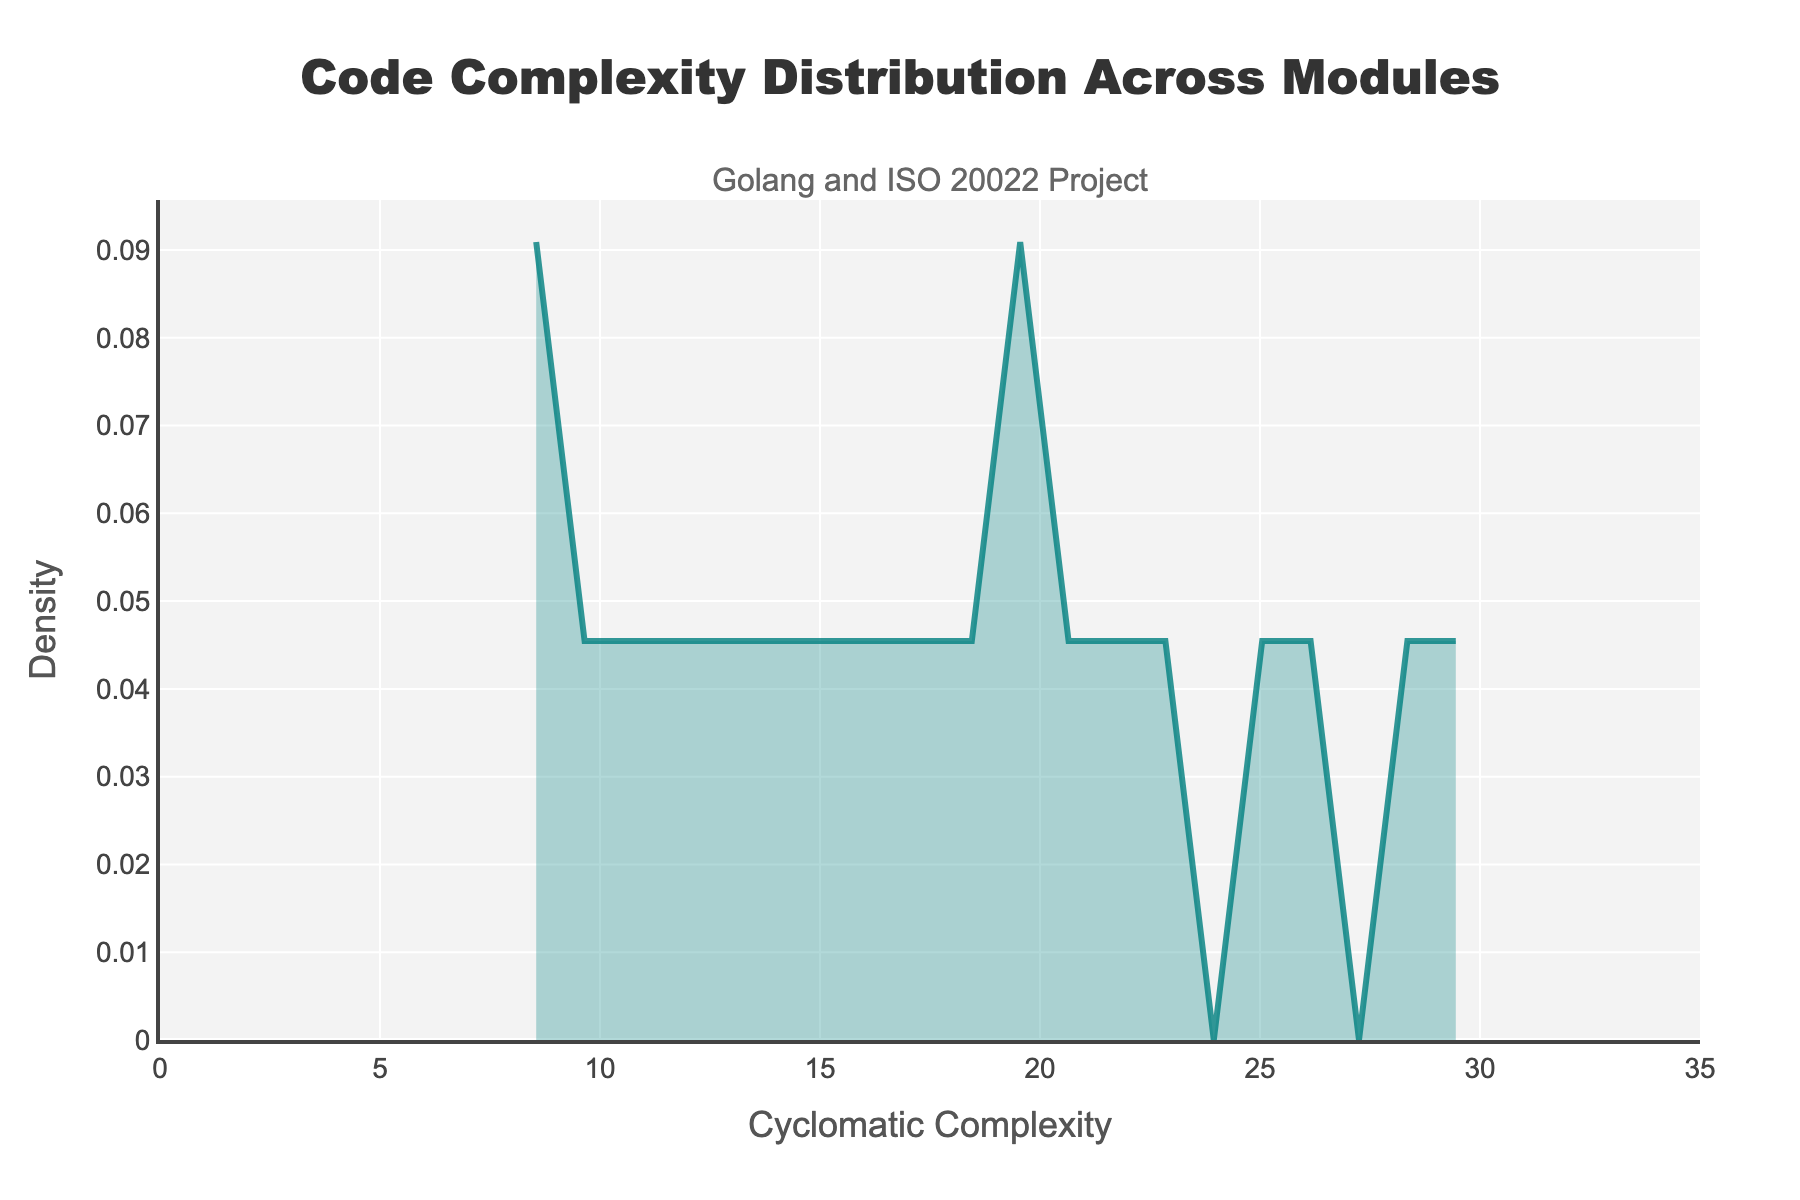what is the title of the density plot? The title of the density plot is located at the top of the plot and reads "Code Complexity Distribution Across Modules".
Answer: Code Complexity Distribution Across Modules What does the x-axis represent in the plot? The label on the x-axis indicates that it represents "Cyclomatic Complexity", quantifying the complexity of the code in each module.
Answer: Cyclomatic Complexity What is the y-axis label, and what does it represent? The y-axis label is "Density", which represents the probability density function of cyclomatic complexity values.
Answer: Density Which module has the highest cyclomatic complexity? By examining the data, the module with the highest cyclomatic complexity (30) is the "iso20022_parser". This corresponds to a density peak in the higher complexity range.
Answer: iso20022_parser What is the general trend observed in the density plot? The density plot shows the distribution of cyclomatic complexity. There are peaks indicating higher density at specific complexity values, showing where most modules' complexities fall.
Answer: Peaks at specific complexity values What is the approximate range of cyclomatic complexity values in the data? By assessing the x-axis range, the cyclomatic complexity values in the data range from about 8 to 30.
Answer: 8 to 30 Which module has a cyclomatic complexity closest to 15? The module with a cyclomatic complexity of 15 is "main", as per the data provided.
Answer: main How many modules have a cyclomatic complexity greater than 20? Based on the data, modules with cyclomatic complexity greater than 20 are api_handlers, iso20022_parser, message_validator, transaction_processor, xml_generator, and scheduler. There are 6 such modules.
Answer: 6 What is the shape of the density plot—does it indicate any skewness? The density plot shape indicates a slightly right-skewed (positively skewed) distribution, with a heavier tail on the higher cyclomatic complexity side.
Answer: Right-skewed 